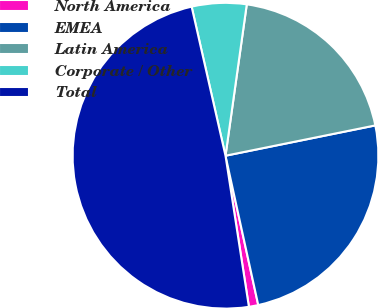<chart> <loc_0><loc_0><loc_500><loc_500><pie_chart><fcel>North America<fcel>EMEA<fcel>Latin America<fcel>Corporate / Other<fcel>Total<nl><fcel>0.99%<fcel>24.74%<fcel>19.6%<fcel>5.78%<fcel>48.89%<nl></chart> 